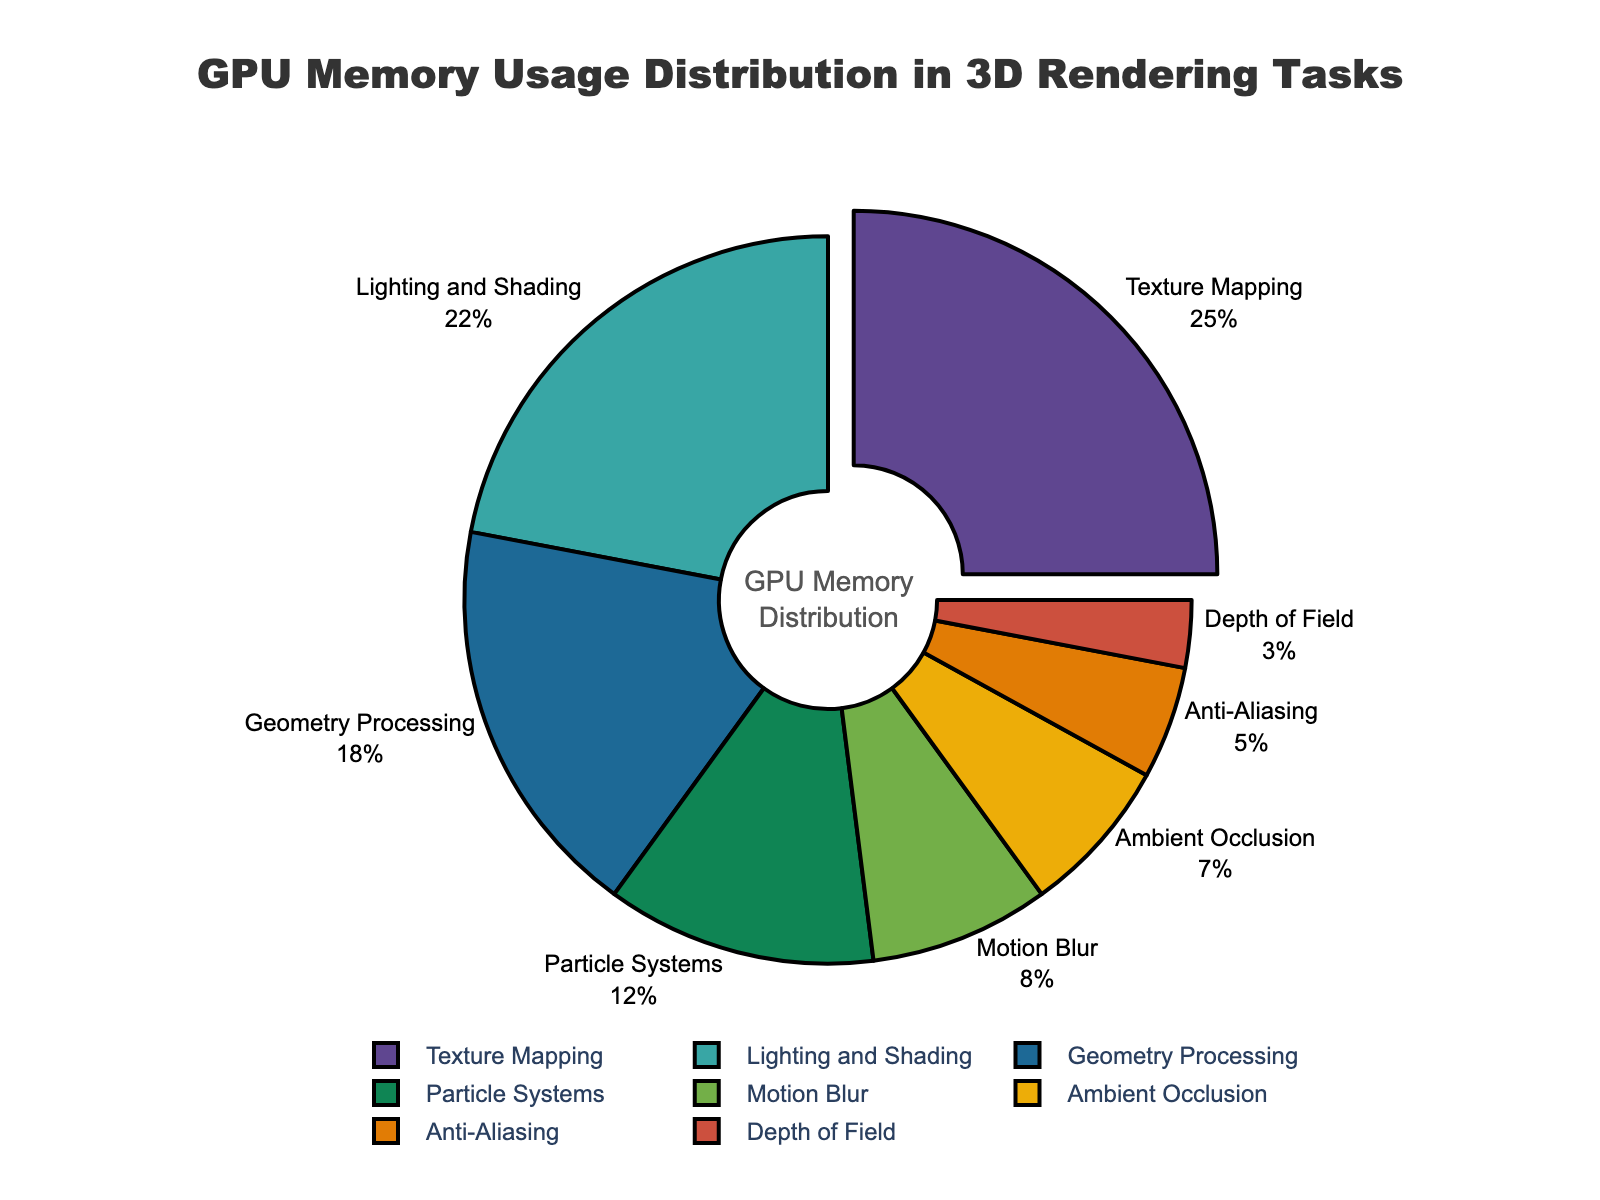What is the task that uses the most GPU memory? Referring to the figure, the segment representing the task with the largest percentage is slightly pulled out for emphasis. This task occupies the highest portion of the pie chart.
Answer: Texture Mapping Which tasks have a combined memory usage higher than Texture Mapping alone? The memory usage for Texture Mapping is 25%. We look at pairs of tasks whose combined memory usage is greater than 25%. For example, Geometry Processing (18%) + Lighting and Shading (22%) = 40%, which is higher than 25%. Similarly, other combinations like Particle Systems (12%) + Lighting and Shading (22%) = 34% are also higher than 25%.
Answer: Geometry Processing + Lighting and Shading What is the total percentage of memory usage by Particle Systems and Depth of Field? Particle Systems use 12% and Depth of Field uses 3% of GPU memory. Adding these together, we get 12% + 3% = 15%.
Answer: 15% Between Lighting and Shading and Ambient Occlusion, which task uses more GPU memory and by how much? Lighting and Shading use 22%, while Ambient Occlusion uses 7%. The difference is 22% - 7% = 15%.
Answer: Lighting and Shading by 15% How does the memory usage of Anti-Aliasing compare to that of Motion Blur? Anti-Aliasing uses 5% and Motion Blur uses 8%. Therefore, Motion Blur uses more GPU memory than Anti-Aliasing.
Answer: Motion Blur uses more Which color represents Geometry Processing in the pie chart? According to the figure, Geometry Processing is assigned a specific color (visible in the legend). Match Geometry Processing's segment in the chart with the corresponding color in the legend.
Answer: (Refer to the figure for the exact color) Is the combined memory usage of Anti-Aliasing and Ambient Occlusion more than Lighting and Shading? Anti-Aliasing uses 5%, and Ambient Occlusion uses 7%. Combined, they use 5% + 7% = 12%. Lighting and Shading use 22%, so no, their combined usage is not more.
Answer: No What is the memory usage percentage for both Motion Blur and Depth of Field together? Motion Blur uses 8% and Depth of Field uses 3%. Adding these together gives 8% + 3% = 11%.
Answer: 11% Does the memory usage of Depth of Field exceed any other single task? The lowest segment is Depth of Field with 3%. Comparing this value with each other segment's memory usage, we can see that all other tasks use more GPU memory than Depth of Field.
Answer: No What is the median value of the memory usage across the reported tasks? The memory usages are 25%, 22%, 18%, 12%, 8%, 7%, 5%, and 3%. Sorting them gives 3%, 5%, 7%, 8%, 12%, 18%, 22%, 25%. The median is the average of the 4th and 5th ranked values: (8% + 12%) / 2 = 10%.
Answer: 10% 